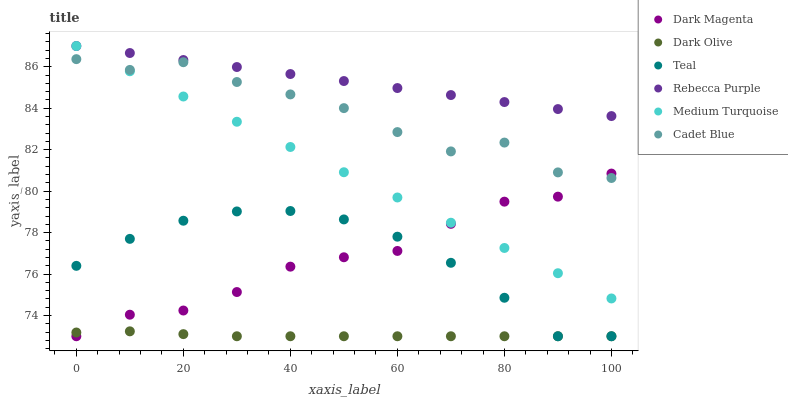Does Dark Olive have the minimum area under the curve?
Answer yes or no. Yes. Does Rebecca Purple have the maximum area under the curve?
Answer yes or no. Yes. Does Cadet Blue have the minimum area under the curve?
Answer yes or no. No. Does Cadet Blue have the maximum area under the curve?
Answer yes or no. No. Is Rebecca Purple the smoothest?
Answer yes or no. Yes. Is Cadet Blue the roughest?
Answer yes or no. Yes. Is Dark Magenta the smoothest?
Answer yes or no. No. Is Dark Magenta the roughest?
Answer yes or no. No. Does Teal have the lowest value?
Answer yes or no. Yes. Does Cadet Blue have the lowest value?
Answer yes or no. No. Does Medium Turquoise have the highest value?
Answer yes or no. Yes. Does Cadet Blue have the highest value?
Answer yes or no. No. Is Dark Magenta less than Rebecca Purple?
Answer yes or no. Yes. Is Cadet Blue greater than Dark Olive?
Answer yes or no. Yes. Does Dark Olive intersect Dark Magenta?
Answer yes or no. Yes. Is Dark Olive less than Dark Magenta?
Answer yes or no. No. Is Dark Olive greater than Dark Magenta?
Answer yes or no. No. Does Dark Magenta intersect Rebecca Purple?
Answer yes or no. No. 